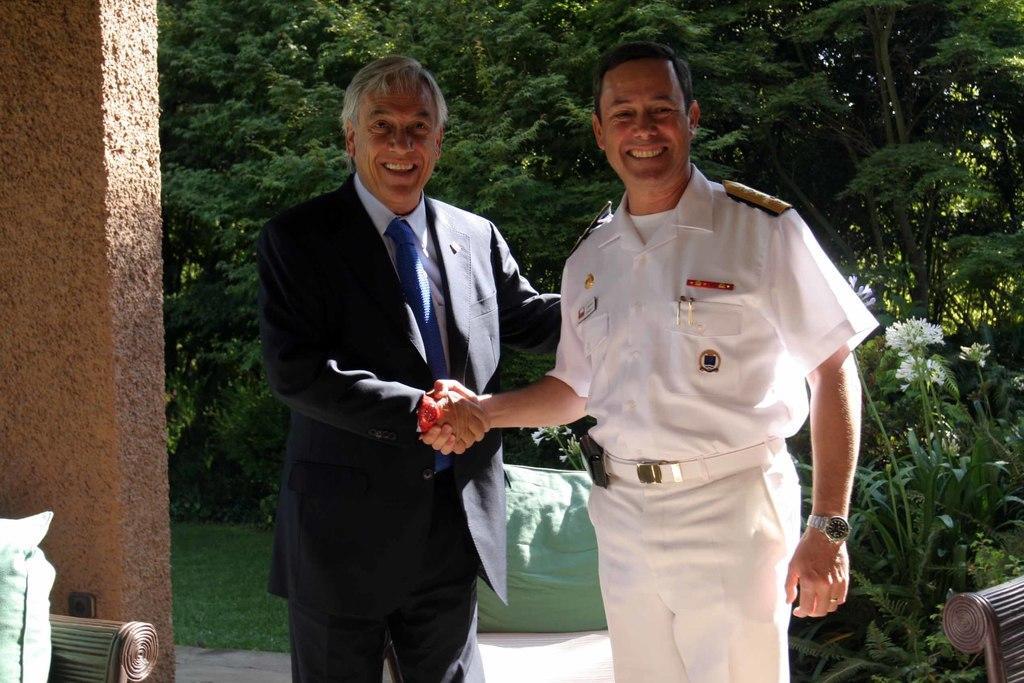How would you summarize this image in a sentence or two? In the front of the image I can see two men are standing, smiling and giving a each-other handshake. In the background of the image there are trees, plants, flowers, grass, wall, pillows and objects.   